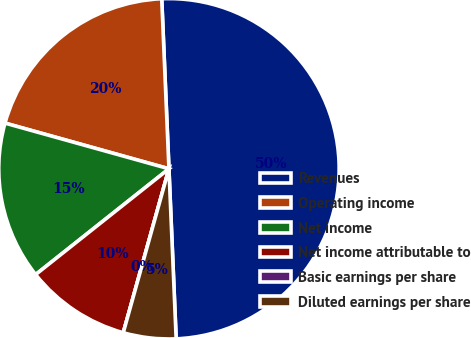<chart> <loc_0><loc_0><loc_500><loc_500><pie_chart><fcel>Revenues<fcel>Operating income<fcel>Net income<fcel>Net income attributable to<fcel>Basic earnings per share<fcel>Diluted earnings per share<nl><fcel>50.0%<fcel>20.0%<fcel>15.0%<fcel>10.0%<fcel>0.0%<fcel>5.0%<nl></chart> 